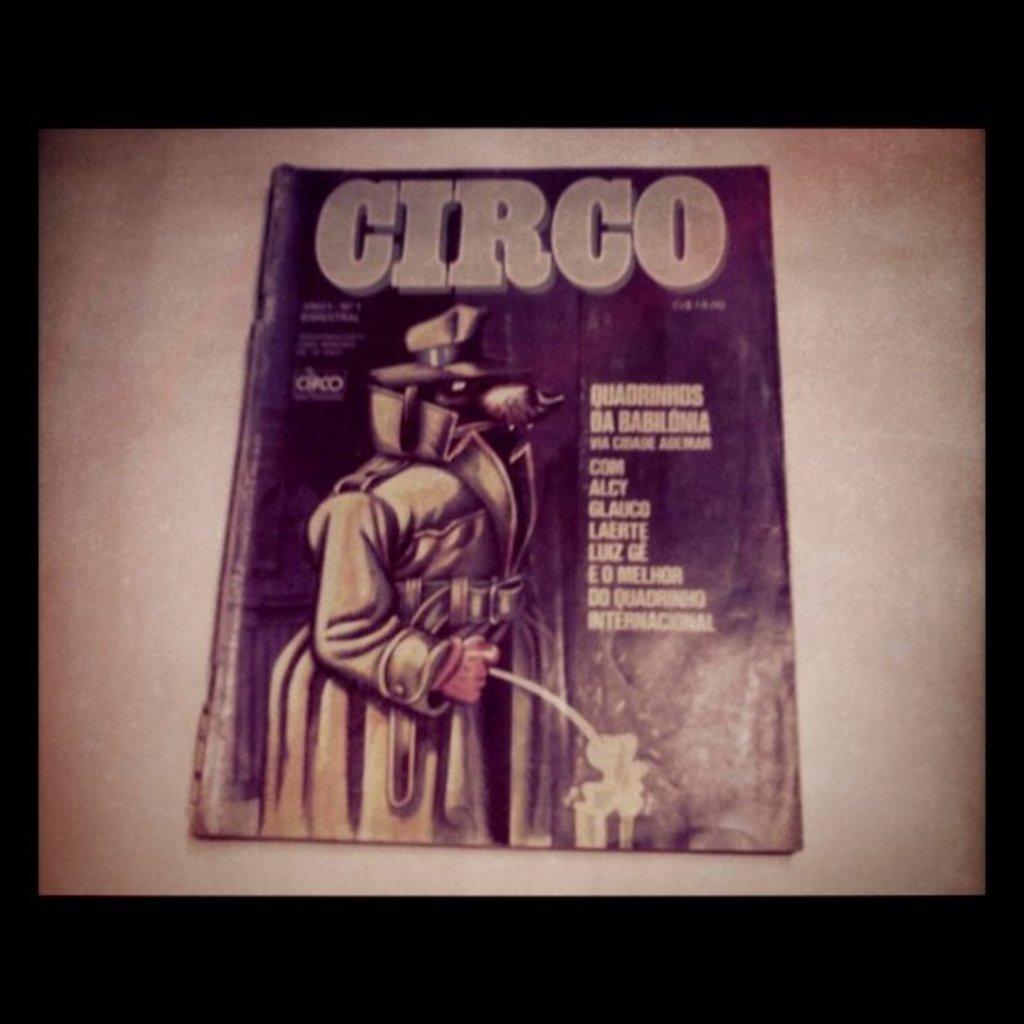What is the name of the publication?
Offer a terse response. Circo. 